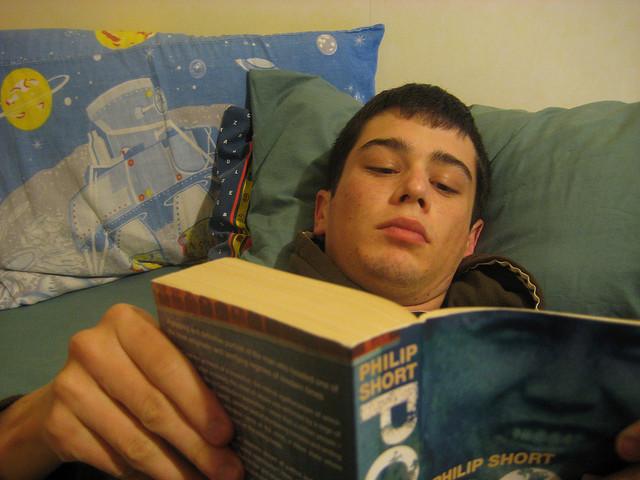What is the book?
Keep it brief. Philip short. What is the theme of the pillow against the wall?
Quick response, please. Space. Is the young man reading pornography?
Concise answer only. No. 